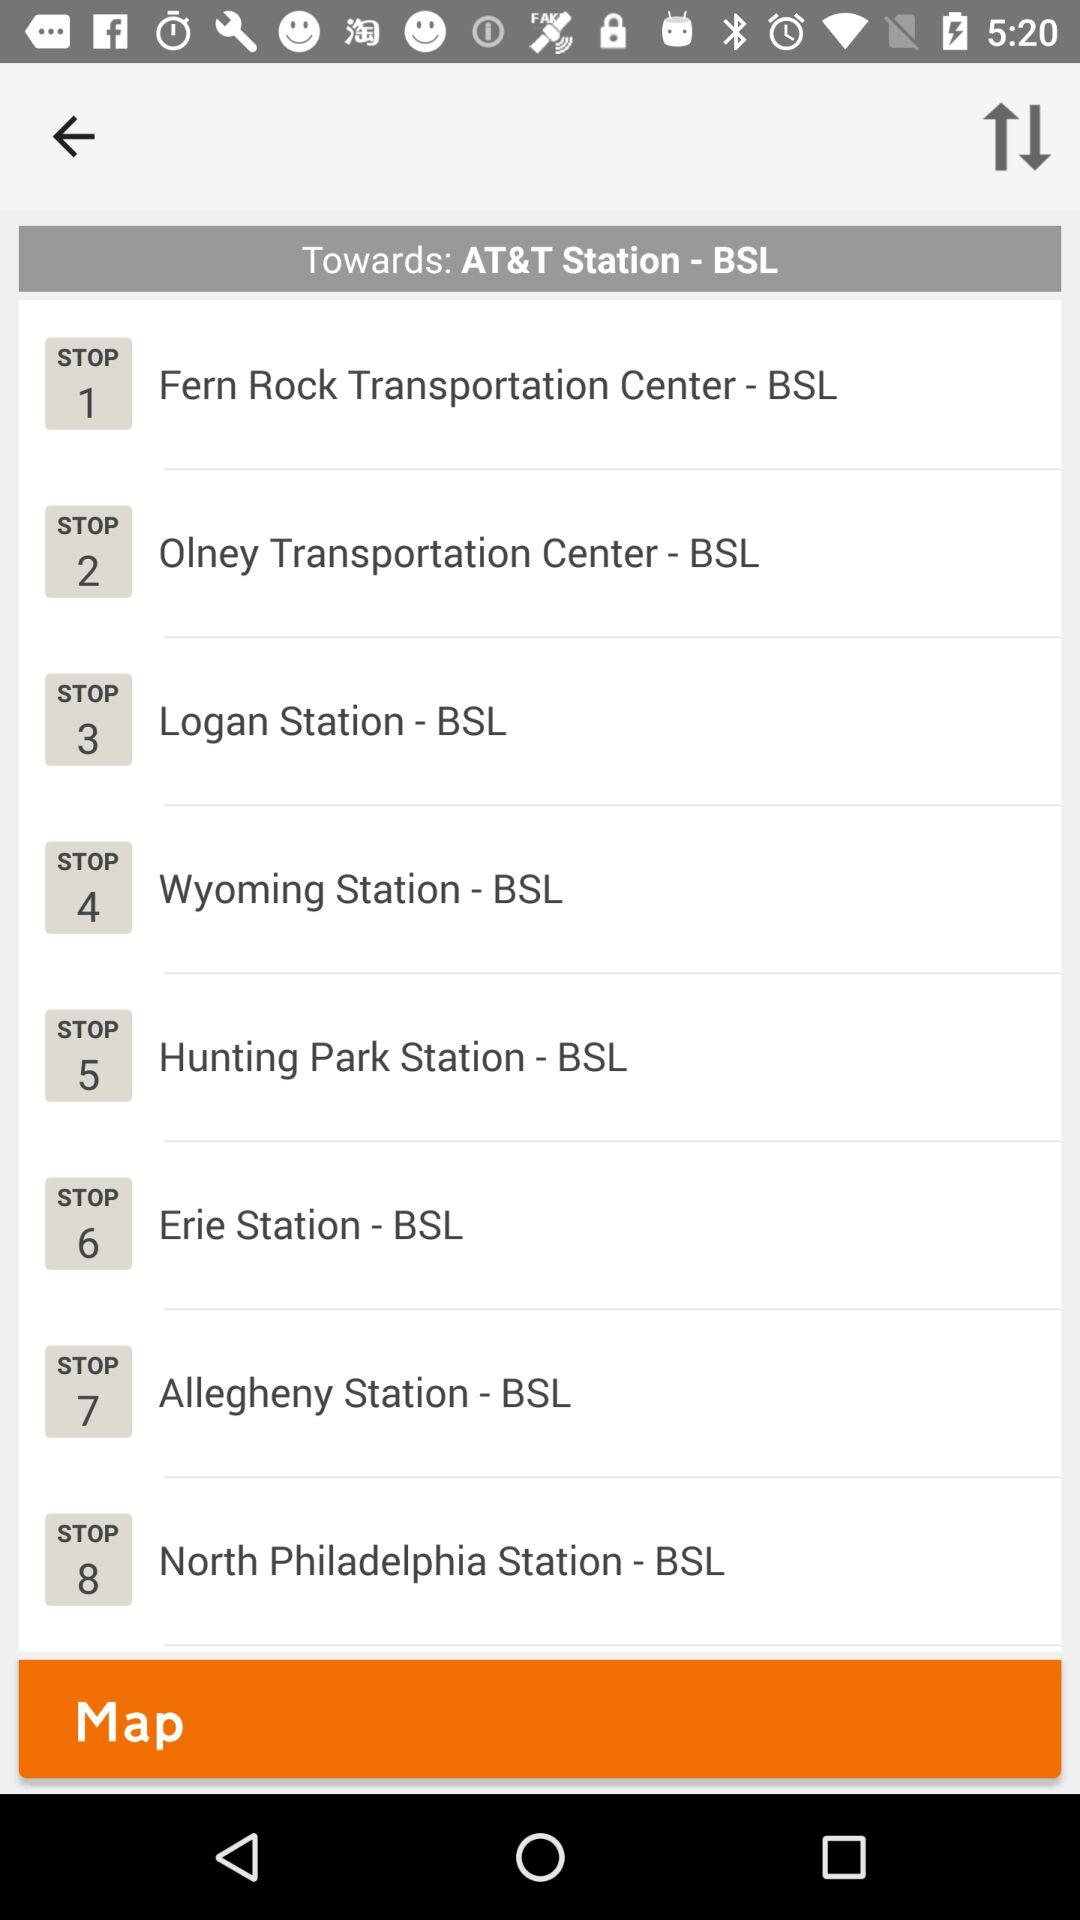What's the destination station? The destination station is AT&T Station. 